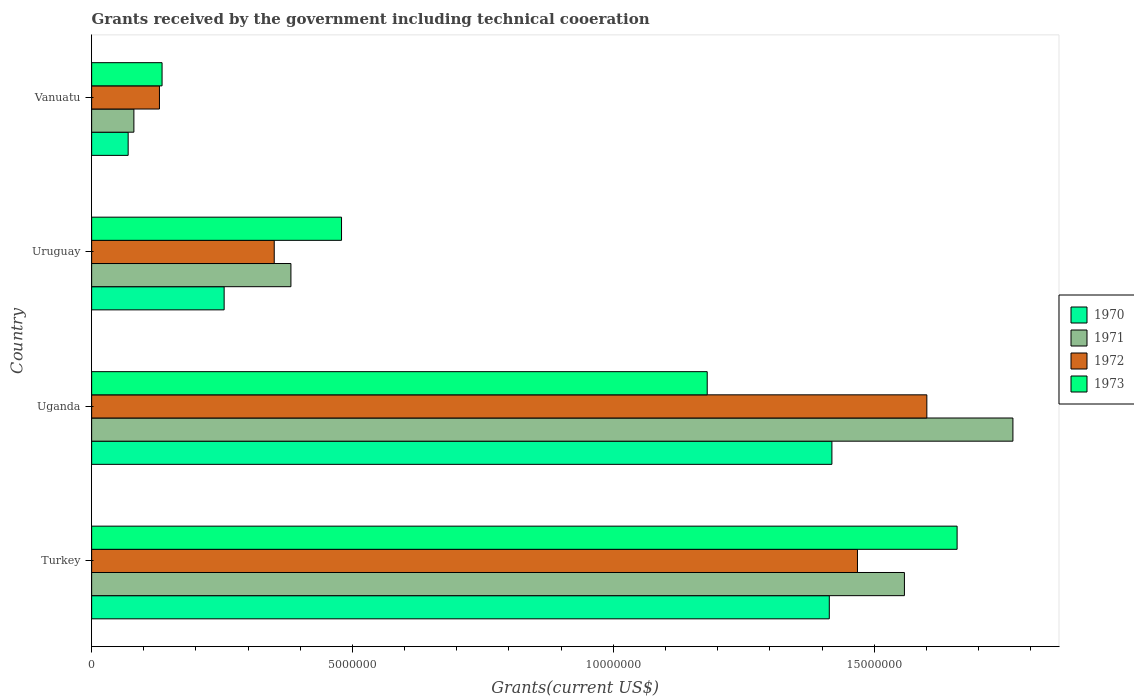Are the number of bars per tick equal to the number of legend labels?
Provide a succinct answer. Yes. Are the number of bars on each tick of the Y-axis equal?
Give a very brief answer. Yes. How many bars are there on the 1st tick from the top?
Offer a very short reply. 4. How many bars are there on the 1st tick from the bottom?
Make the answer very short. 4. What is the label of the 3rd group of bars from the top?
Ensure brevity in your answer.  Uganda. In how many cases, is the number of bars for a given country not equal to the number of legend labels?
Provide a short and direct response. 0. What is the total grants received by the government in 1972 in Uganda?
Provide a succinct answer. 1.60e+07. Across all countries, what is the maximum total grants received by the government in 1971?
Provide a short and direct response. 1.77e+07. Across all countries, what is the minimum total grants received by the government in 1972?
Make the answer very short. 1.30e+06. In which country was the total grants received by the government in 1971 maximum?
Keep it short and to the point. Uganda. In which country was the total grants received by the government in 1973 minimum?
Your answer should be very brief. Vanuatu. What is the total total grants received by the government in 1972 in the graph?
Offer a very short reply. 3.55e+07. What is the difference between the total grants received by the government in 1972 in Turkey and that in Uruguay?
Give a very brief answer. 1.12e+07. What is the difference between the total grants received by the government in 1973 in Turkey and the total grants received by the government in 1970 in Uganda?
Give a very brief answer. 2.40e+06. What is the average total grants received by the government in 1972 per country?
Your answer should be compact. 8.87e+06. What is the difference between the total grants received by the government in 1973 and total grants received by the government in 1971 in Turkey?
Provide a short and direct response. 1.01e+06. What is the ratio of the total grants received by the government in 1972 in Uruguay to that in Vanuatu?
Provide a succinct answer. 2.69. Is the difference between the total grants received by the government in 1973 in Turkey and Uganda greater than the difference between the total grants received by the government in 1971 in Turkey and Uganda?
Keep it short and to the point. Yes. What is the difference between the highest and the second highest total grants received by the government in 1970?
Provide a succinct answer. 5.00e+04. What is the difference between the highest and the lowest total grants received by the government in 1973?
Your answer should be very brief. 1.52e+07. What does the 1st bar from the top in Vanuatu represents?
Offer a very short reply. 1973. What does the 3rd bar from the bottom in Uruguay represents?
Provide a succinct answer. 1972. Are the values on the major ticks of X-axis written in scientific E-notation?
Offer a very short reply. No. Does the graph contain any zero values?
Offer a very short reply. No. Does the graph contain grids?
Keep it short and to the point. No. Where does the legend appear in the graph?
Your response must be concise. Center right. What is the title of the graph?
Offer a terse response. Grants received by the government including technical cooeration. Does "1978" appear as one of the legend labels in the graph?
Ensure brevity in your answer.  No. What is the label or title of the X-axis?
Give a very brief answer. Grants(current US$). What is the Grants(current US$) of 1970 in Turkey?
Offer a very short reply. 1.41e+07. What is the Grants(current US$) of 1971 in Turkey?
Your response must be concise. 1.56e+07. What is the Grants(current US$) of 1972 in Turkey?
Your answer should be compact. 1.47e+07. What is the Grants(current US$) in 1973 in Turkey?
Offer a very short reply. 1.66e+07. What is the Grants(current US$) of 1970 in Uganda?
Provide a short and direct response. 1.42e+07. What is the Grants(current US$) in 1971 in Uganda?
Provide a succinct answer. 1.77e+07. What is the Grants(current US$) of 1972 in Uganda?
Your answer should be compact. 1.60e+07. What is the Grants(current US$) in 1973 in Uganda?
Your response must be concise. 1.18e+07. What is the Grants(current US$) of 1970 in Uruguay?
Provide a succinct answer. 2.54e+06. What is the Grants(current US$) in 1971 in Uruguay?
Your answer should be very brief. 3.82e+06. What is the Grants(current US$) of 1972 in Uruguay?
Make the answer very short. 3.50e+06. What is the Grants(current US$) of 1973 in Uruguay?
Keep it short and to the point. 4.79e+06. What is the Grants(current US$) in 1971 in Vanuatu?
Your answer should be compact. 8.10e+05. What is the Grants(current US$) of 1972 in Vanuatu?
Give a very brief answer. 1.30e+06. What is the Grants(current US$) in 1973 in Vanuatu?
Provide a short and direct response. 1.35e+06. Across all countries, what is the maximum Grants(current US$) in 1970?
Your response must be concise. 1.42e+07. Across all countries, what is the maximum Grants(current US$) of 1971?
Keep it short and to the point. 1.77e+07. Across all countries, what is the maximum Grants(current US$) of 1972?
Keep it short and to the point. 1.60e+07. Across all countries, what is the maximum Grants(current US$) in 1973?
Offer a very short reply. 1.66e+07. Across all countries, what is the minimum Grants(current US$) of 1971?
Offer a terse response. 8.10e+05. Across all countries, what is the minimum Grants(current US$) in 1972?
Offer a very short reply. 1.30e+06. Across all countries, what is the minimum Grants(current US$) in 1973?
Offer a very short reply. 1.35e+06. What is the total Grants(current US$) in 1970 in the graph?
Give a very brief answer. 3.16e+07. What is the total Grants(current US$) of 1971 in the graph?
Keep it short and to the point. 3.79e+07. What is the total Grants(current US$) in 1972 in the graph?
Your answer should be compact. 3.55e+07. What is the total Grants(current US$) of 1973 in the graph?
Make the answer very short. 3.45e+07. What is the difference between the Grants(current US$) of 1970 in Turkey and that in Uganda?
Offer a very short reply. -5.00e+04. What is the difference between the Grants(current US$) of 1971 in Turkey and that in Uganda?
Ensure brevity in your answer.  -2.08e+06. What is the difference between the Grants(current US$) of 1972 in Turkey and that in Uganda?
Your response must be concise. -1.33e+06. What is the difference between the Grants(current US$) of 1973 in Turkey and that in Uganda?
Ensure brevity in your answer.  4.79e+06. What is the difference between the Grants(current US$) in 1970 in Turkey and that in Uruguay?
Offer a very short reply. 1.16e+07. What is the difference between the Grants(current US$) of 1971 in Turkey and that in Uruguay?
Make the answer very short. 1.18e+07. What is the difference between the Grants(current US$) in 1972 in Turkey and that in Uruguay?
Provide a short and direct response. 1.12e+07. What is the difference between the Grants(current US$) of 1973 in Turkey and that in Uruguay?
Keep it short and to the point. 1.18e+07. What is the difference between the Grants(current US$) in 1970 in Turkey and that in Vanuatu?
Make the answer very short. 1.34e+07. What is the difference between the Grants(current US$) in 1971 in Turkey and that in Vanuatu?
Offer a very short reply. 1.48e+07. What is the difference between the Grants(current US$) of 1972 in Turkey and that in Vanuatu?
Make the answer very short. 1.34e+07. What is the difference between the Grants(current US$) of 1973 in Turkey and that in Vanuatu?
Keep it short and to the point. 1.52e+07. What is the difference between the Grants(current US$) in 1970 in Uganda and that in Uruguay?
Provide a succinct answer. 1.16e+07. What is the difference between the Grants(current US$) of 1971 in Uganda and that in Uruguay?
Provide a succinct answer. 1.38e+07. What is the difference between the Grants(current US$) in 1972 in Uganda and that in Uruguay?
Your response must be concise. 1.25e+07. What is the difference between the Grants(current US$) in 1973 in Uganda and that in Uruguay?
Offer a very short reply. 7.01e+06. What is the difference between the Grants(current US$) in 1970 in Uganda and that in Vanuatu?
Provide a short and direct response. 1.35e+07. What is the difference between the Grants(current US$) of 1971 in Uganda and that in Vanuatu?
Make the answer very short. 1.68e+07. What is the difference between the Grants(current US$) in 1972 in Uganda and that in Vanuatu?
Give a very brief answer. 1.47e+07. What is the difference between the Grants(current US$) in 1973 in Uganda and that in Vanuatu?
Offer a terse response. 1.04e+07. What is the difference between the Grants(current US$) of 1970 in Uruguay and that in Vanuatu?
Your answer should be very brief. 1.84e+06. What is the difference between the Grants(current US$) in 1971 in Uruguay and that in Vanuatu?
Make the answer very short. 3.01e+06. What is the difference between the Grants(current US$) of 1972 in Uruguay and that in Vanuatu?
Provide a short and direct response. 2.20e+06. What is the difference between the Grants(current US$) of 1973 in Uruguay and that in Vanuatu?
Keep it short and to the point. 3.44e+06. What is the difference between the Grants(current US$) of 1970 in Turkey and the Grants(current US$) of 1971 in Uganda?
Offer a very short reply. -3.52e+06. What is the difference between the Grants(current US$) of 1970 in Turkey and the Grants(current US$) of 1972 in Uganda?
Provide a succinct answer. -1.87e+06. What is the difference between the Grants(current US$) of 1970 in Turkey and the Grants(current US$) of 1973 in Uganda?
Give a very brief answer. 2.34e+06. What is the difference between the Grants(current US$) of 1971 in Turkey and the Grants(current US$) of 1972 in Uganda?
Give a very brief answer. -4.30e+05. What is the difference between the Grants(current US$) in 1971 in Turkey and the Grants(current US$) in 1973 in Uganda?
Your answer should be very brief. 3.78e+06. What is the difference between the Grants(current US$) of 1972 in Turkey and the Grants(current US$) of 1973 in Uganda?
Give a very brief answer. 2.88e+06. What is the difference between the Grants(current US$) in 1970 in Turkey and the Grants(current US$) in 1971 in Uruguay?
Your answer should be compact. 1.03e+07. What is the difference between the Grants(current US$) of 1970 in Turkey and the Grants(current US$) of 1972 in Uruguay?
Provide a short and direct response. 1.06e+07. What is the difference between the Grants(current US$) in 1970 in Turkey and the Grants(current US$) in 1973 in Uruguay?
Offer a very short reply. 9.35e+06. What is the difference between the Grants(current US$) of 1971 in Turkey and the Grants(current US$) of 1972 in Uruguay?
Offer a very short reply. 1.21e+07. What is the difference between the Grants(current US$) of 1971 in Turkey and the Grants(current US$) of 1973 in Uruguay?
Keep it short and to the point. 1.08e+07. What is the difference between the Grants(current US$) in 1972 in Turkey and the Grants(current US$) in 1973 in Uruguay?
Provide a succinct answer. 9.89e+06. What is the difference between the Grants(current US$) in 1970 in Turkey and the Grants(current US$) in 1971 in Vanuatu?
Your answer should be compact. 1.33e+07. What is the difference between the Grants(current US$) in 1970 in Turkey and the Grants(current US$) in 1972 in Vanuatu?
Make the answer very short. 1.28e+07. What is the difference between the Grants(current US$) of 1970 in Turkey and the Grants(current US$) of 1973 in Vanuatu?
Offer a very short reply. 1.28e+07. What is the difference between the Grants(current US$) in 1971 in Turkey and the Grants(current US$) in 1972 in Vanuatu?
Your response must be concise. 1.43e+07. What is the difference between the Grants(current US$) of 1971 in Turkey and the Grants(current US$) of 1973 in Vanuatu?
Provide a succinct answer. 1.42e+07. What is the difference between the Grants(current US$) in 1972 in Turkey and the Grants(current US$) in 1973 in Vanuatu?
Give a very brief answer. 1.33e+07. What is the difference between the Grants(current US$) in 1970 in Uganda and the Grants(current US$) in 1971 in Uruguay?
Your answer should be very brief. 1.04e+07. What is the difference between the Grants(current US$) of 1970 in Uganda and the Grants(current US$) of 1972 in Uruguay?
Provide a short and direct response. 1.07e+07. What is the difference between the Grants(current US$) of 1970 in Uganda and the Grants(current US$) of 1973 in Uruguay?
Keep it short and to the point. 9.40e+06. What is the difference between the Grants(current US$) of 1971 in Uganda and the Grants(current US$) of 1972 in Uruguay?
Give a very brief answer. 1.42e+07. What is the difference between the Grants(current US$) in 1971 in Uganda and the Grants(current US$) in 1973 in Uruguay?
Your response must be concise. 1.29e+07. What is the difference between the Grants(current US$) of 1972 in Uganda and the Grants(current US$) of 1973 in Uruguay?
Make the answer very short. 1.12e+07. What is the difference between the Grants(current US$) of 1970 in Uganda and the Grants(current US$) of 1971 in Vanuatu?
Provide a short and direct response. 1.34e+07. What is the difference between the Grants(current US$) of 1970 in Uganda and the Grants(current US$) of 1972 in Vanuatu?
Make the answer very short. 1.29e+07. What is the difference between the Grants(current US$) of 1970 in Uganda and the Grants(current US$) of 1973 in Vanuatu?
Your answer should be very brief. 1.28e+07. What is the difference between the Grants(current US$) of 1971 in Uganda and the Grants(current US$) of 1972 in Vanuatu?
Your answer should be compact. 1.64e+07. What is the difference between the Grants(current US$) of 1971 in Uganda and the Grants(current US$) of 1973 in Vanuatu?
Your answer should be very brief. 1.63e+07. What is the difference between the Grants(current US$) in 1972 in Uganda and the Grants(current US$) in 1973 in Vanuatu?
Make the answer very short. 1.47e+07. What is the difference between the Grants(current US$) in 1970 in Uruguay and the Grants(current US$) in 1971 in Vanuatu?
Give a very brief answer. 1.73e+06. What is the difference between the Grants(current US$) of 1970 in Uruguay and the Grants(current US$) of 1972 in Vanuatu?
Offer a terse response. 1.24e+06. What is the difference between the Grants(current US$) in 1970 in Uruguay and the Grants(current US$) in 1973 in Vanuatu?
Provide a succinct answer. 1.19e+06. What is the difference between the Grants(current US$) in 1971 in Uruguay and the Grants(current US$) in 1972 in Vanuatu?
Offer a terse response. 2.52e+06. What is the difference between the Grants(current US$) in 1971 in Uruguay and the Grants(current US$) in 1973 in Vanuatu?
Your answer should be compact. 2.47e+06. What is the difference between the Grants(current US$) of 1972 in Uruguay and the Grants(current US$) of 1973 in Vanuatu?
Your response must be concise. 2.15e+06. What is the average Grants(current US$) of 1970 per country?
Your answer should be compact. 7.89e+06. What is the average Grants(current US$) in 1971 per country?
Make the answer very short. 9.47e+06. What is the average Grants(current US$) of 1972 per country?
Give a very brief answer. 8.87e+06. What is the average Grants(current US$) of 1973 per country?
Make the answer very short. 8.63e+06. What is the difference between the Grants(current US$) in 1970 and Grants(current US$) in 1971 in Turkey?
Ensure brevity in your answer.  -1.44e+06. What is the difference between the Grants(current US$) of 1970 and Grants(current US$) of 1972 in Turkey?
Your answer should be compact. -5.40e+05. What is the difference between the Grants(current US$) of 1970 and Grants(current US$) of 1973 in Turkey?
Your response must be concise. -2.45e+06. What is the difference between the Grants(current US$) in 1971 and Grants(current US$) in 1973 in Turkey?
Your response must be concise. -1.01e+06. What is the difference between the Grants(current US$) of 1972 and Grants(current US$) of 1973 in Turkey?
Offer a very short reply. -1.91e+06. What is the difference between the Grants(current US$) in 1970 and Grants(current US$) in 1971 in Uganda?
Give a very brief answer. -3.47e+06. What is the difference between the Grants(current US$) in 1970 and Grants(current US$) in 1972 in Uganda?
Offer a very short reply. -1.82e+06. What is the difference between the Grants(current US$) in 1970 and Grants(current US$) in 1973 in Uganda?
Your response must be concise. 2.39e+06. What is the difference between the Grants(current US$) in 1971 and Grants(current US$) in 1972 in Uganda?
Provide a short and direct response. 1.65e+06. What is the difference between the Grants(current US$) in 1971 and Grants(current US$) in 1973 in Uganda?
Your answer should be very brief. 5.86e+06. What is the difference between the Grants(current US$) in 1972 and Grants(current US$) in 1973 in Uganda?
Offer a terse response. 4.21e+06. What is the difference between the Grants(current US$) of 1970 and Grants(current US$) of 1971 in Uruguay?
Offer a very short reply. -1.28e+06. What is the difference between the Grants(current US$) of 1970 and Grants(current US$) of 1972 in Uruguay?
Your answer should be compact. -9.60e+05. What is the difference between the Grants(current US$) of 1970 and Grants(current US$) of 1973 in Uruguay?
Offer a terse response. -2.25e+06. What is the difference between the Grants(current US$) of 1971 and Grants(current US$) of 1972 in Uruguay?
Offer a very short reply. 3.20e+05. What is the difference between the Grants(current US$) in 1971 and Grants(current US$) in 1973 in Uruguay?
Make the answer very short. -9.70e+05. What is the difference between the Grants(current US$) in 1972 and Grants(current US$) in 1973 in Uruguay?
Your response must be concise. -1.29e+06. What is the difference between the Grants(current US$) in 1970 and Grants(current US$) in 1972 in Vanuatu?
Your answer should be compact. -6.00e+05. What is the difference between the Grants(current US$) of 1970 and Grants(current US$) of 1973 in Vanuatu?
Make the answer very short. -6.50e+05. What is the difference between the Grants(current US$) of 1971 and Grants(current US$) of 1972 in Vanuatu?
Provide a short and direct response. -4.90e+05. What is the difference between the Grants(current US$) in 1971 and Grants(current US$) in 1973 in Vanuatu?
Ensure brevity in your answer.  -5.40e+05. What is the difference between the Grants(current US$) in 1972 and Grants(current US$) in 1973 in Vanuatu?
Ensure brevity in your answer.  -5.00e+04. What is the ratio of the Grants(current US$) of 1970 in Turkey to that in Uganda?
Provide a succinct answer. 1. What is the ratio of the Grants(current US$) in 1971 in Turkey to that in Uganda?
Provide a succinct answer. 0.88. What is the ratio of the Grants(current US$) in 1972 in Turkey to that in Uganda?
Your answer should be compact. 0.92. What is the ratio of the Grants(current US$) of 1973 in Turkey to that in Uganda?
Keep it short and to the point. 1.41. What is the ratio of the Grants(current US$) of 1970 in Turkey to that in Uruguay?
Offer a very short reply. 5.57. What is the ratio of the Grants(current US$) of 1971 in Turkey to that in Uruguay?
Your answer should be very brief. 4.08. What is the ratio of the Grants(current US$) of 1972 in Turkey to that in Uruguay?
Your answer should be compact. 4.19. What is the ratio of the Grants(current US$) of 1973 in Turkey to that in Uruguay?
Provide a succinct answer. 3.46. What is the ratio of the Grants(current US$) of 1970 in Turkey to that in Vanuatu?
Your answer should be compact. 20.2. What is the ratio of the Grants(current US$) of 1971 in Turkey to that in Vanuatu?
Your answer should be very brief. 19.23. What is the ratio of the Grants(current US$) in 1972 in Turkey to that in Vanuatu?
Provide a short and direct response. 11.29. What is the ratio of the Grants(current US$) of 1973 in Turkey to that in Vanuatu?
Make the answer very short. 12.29. What is the ratio of the Grants(current US$) of 1970 in Uganda to that in Uruguay?
Make the answer very short. 5.59. What is the ratio of the Grants(current US$) of 1971 in Uganda to that in Uruguay?
Provide a short and direct response. 4.62. What is the ratio of the Grants(current US$) in 1972 in Uganda to that in Uruguay?
Offer a very short reply. 4.57. What is the ratio of the Grants(current US$) of 1973 in Uganda to that in Uruguay?
Make the answer very short. 2.46. What is the ratio of the Grants(current US$) in 1970 in Uganda to that in Vanuatu?
Offer a very short reply. 20.27. What is the ratio of the Grants(current US$) of 1971 in Uganda to that in Vanuatu?
Give a very brief answer. 21.8. What is the ratio of the Grants(current US$) of 1972 in Uganda to that in Vanuatu?
Offer a terse response. 12.32. What is the ratio of the Grants(current US$) in 1973 in Uganda to that in Vanuatu?
Make the answer very short. 8.74. What is the ratio of the Grants(current US$) in 1970 in Uruguay to that in Vanuatu?
Offer a terse response. 3.63. What is the ratio of the Grants(current US$) of 1971 in Uruguay to that in Vanuatu?
Your answer should be very brief. 4.72. What is the ratio of the Grants(current US$) of 1972 in Uruguay to that in Vanuatu?
Give a very brief answer. 2.69. What is the ratio of the Grants(current US$) of 1973 in Uruguay to that in Vanuatu?
Make the answer very short. 3.55. What is the difference between the highest and the second highest Grants(current US$) of 1971?
Keep it short and to the point. 2.08e+06. What is the difference between the highest and the second highest Grants(current US$) in 1972?
Your response must be concise. 1.33e+06. What is the difference between the highest and the second highest Grants(current US$) in 1973?
Your response must be concise. 4.79e+06. What is the difference between the highest and the lowest Grants(current US$) of 1970?
Keep it short and to the point. 1.35e+07. What is the difference between the highest and the lowest Grants(current US$) in 1971?
Provide a short and direct response. 1.68e+07. What is the difference between the highest and the lowest Grants(current US$) in 1972?
Your answer should be very brief. 1.47e+07. What is the difference between the highest and the lowest Grants(current US$) in 1973?
Keep it short and to the point. 1.52e+07. 